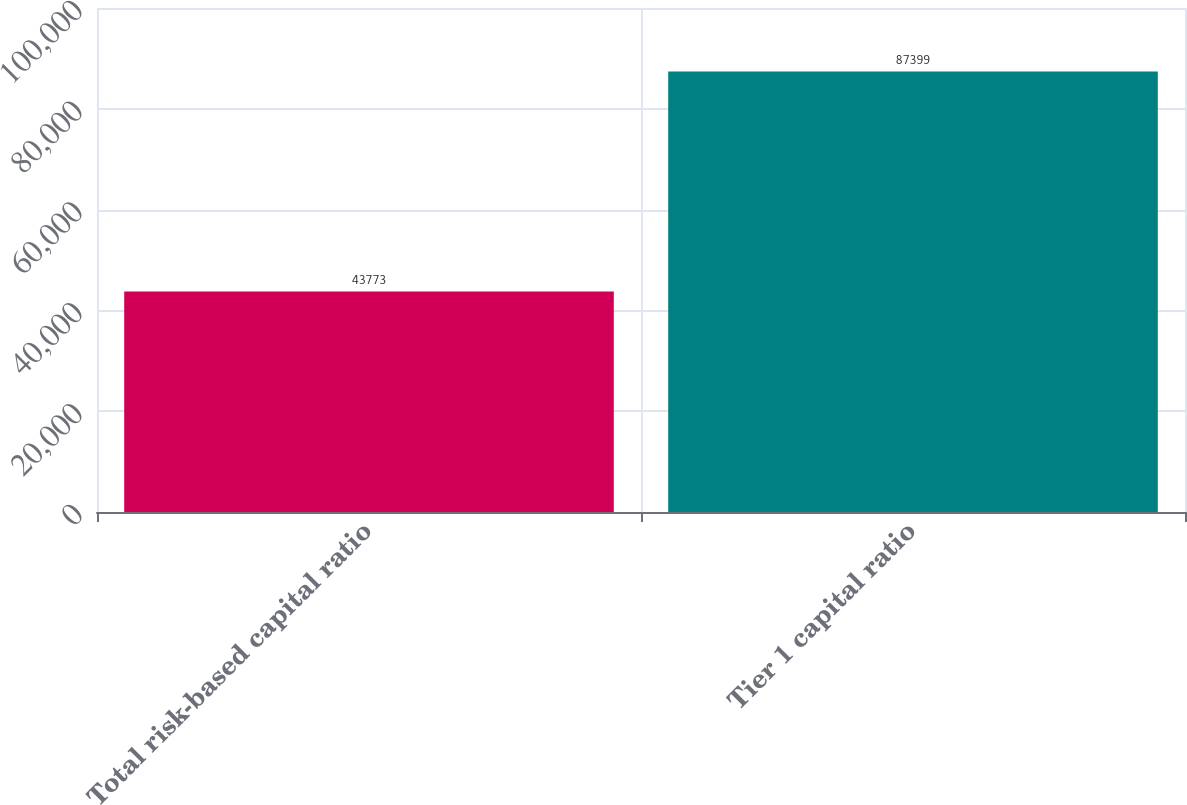Convert chart. <chart><loc_0><loc_0><loc_500><loc_500><bar_chart><fcel>Total risk-based capital ratio<fcel>Tier 1 capital ratio<nl><fcel>43773<fcel>87399<nl></chart> 